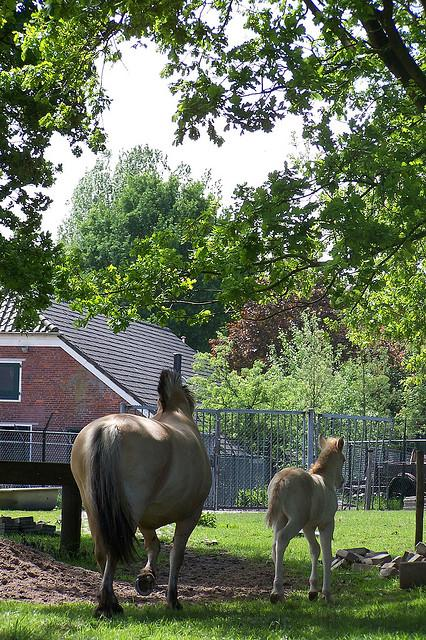What are the horses doing?

Choices:
A) swimming
B) sleeping
C) standing
D) flying standing 